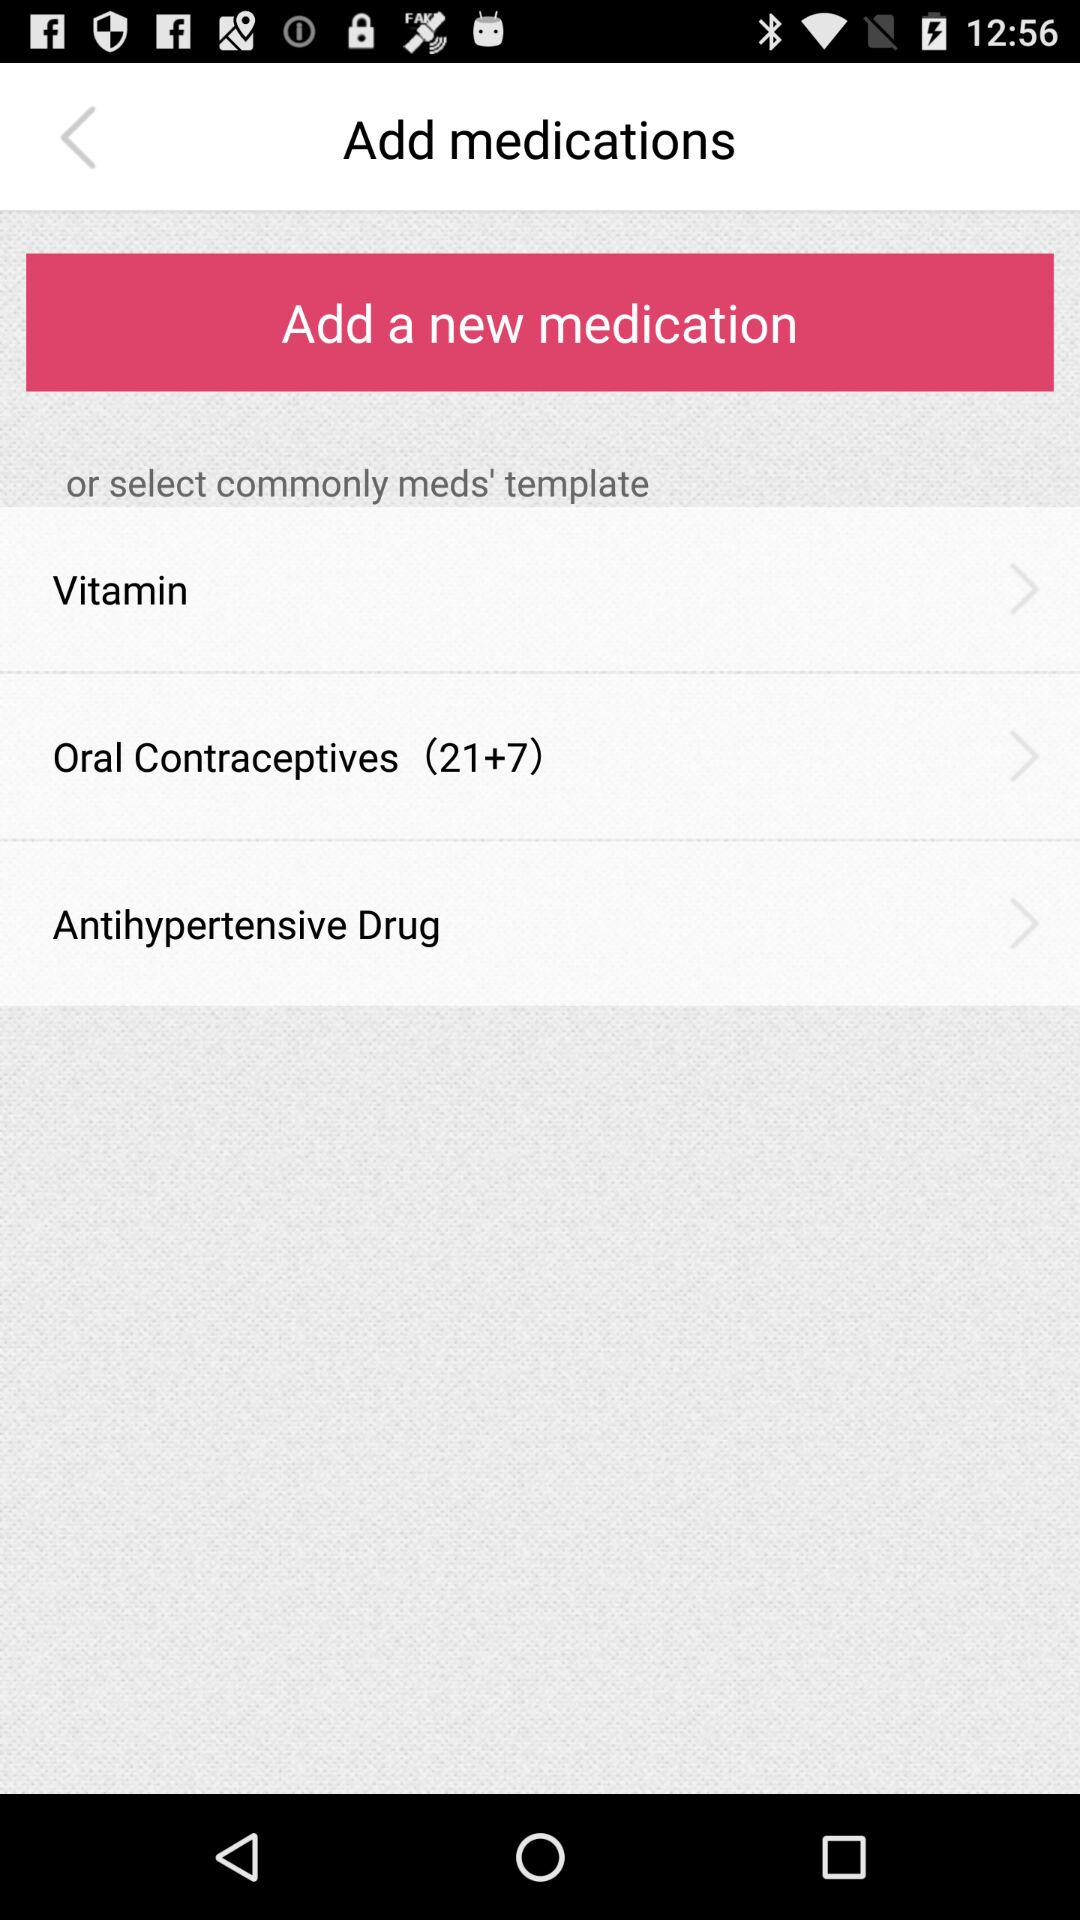How many medication templates are displayed?
Answer the question using a single word or phrase. 3 